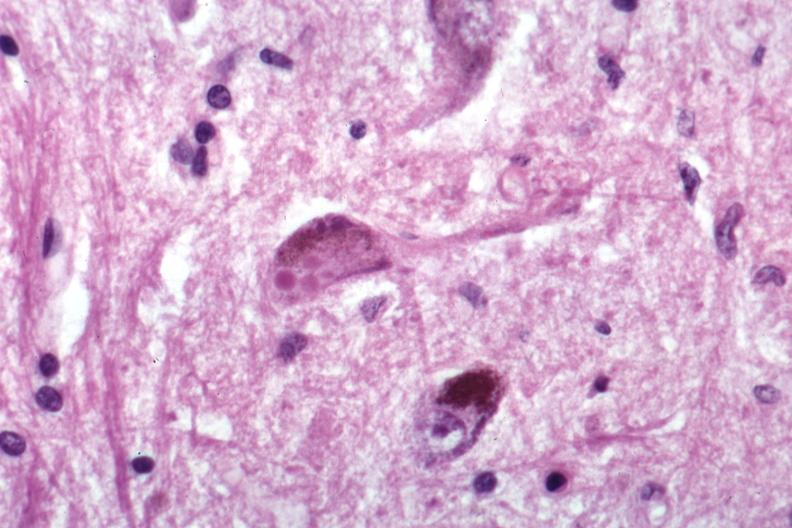what is present?
Answer the question using a single word or phrase. Lewy body 